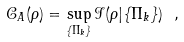Convert formula to latex. <formula><loc_0><loc_0><loc_500><loc_500>\mathcal { C } _ { A } ( \rho ) = \sup _ { \{ \Pi _ { k } \} } \mathcal { I } ( \rho | \{ \Pi _ { k } \} ) \ ,</formula> 